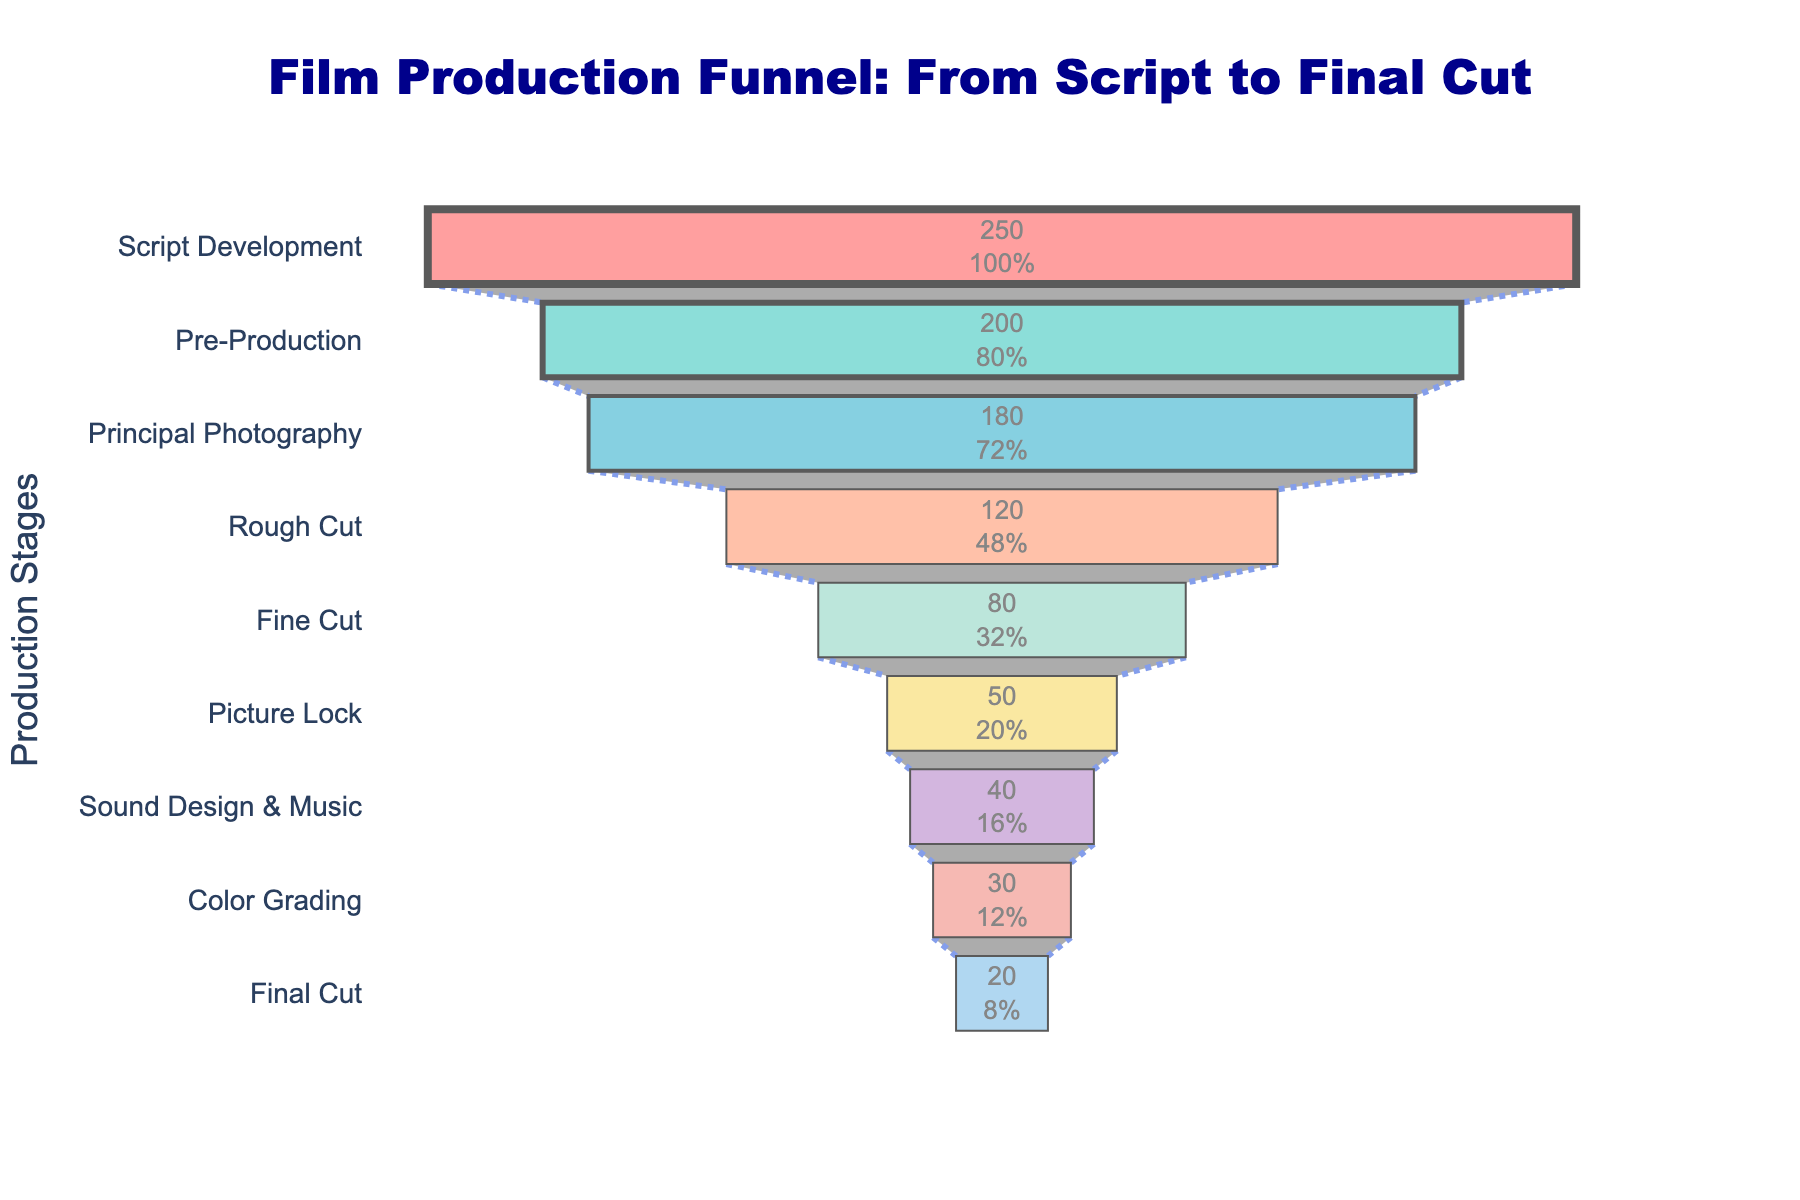What is the title of the funnel chart? The title appears at the top of the funnel chart and indicates the overall theme or topic.
Answer: Film Production Funnel: From Script to Final Cut Which stage has the most people involved? By examining the y-axis labels and the lengths of the bars in the funnel chart, the longest bar corresponds to the stage with the most people involved.
Answer: Script Development How many stages are depicted in the funnel chart? Count the number of distinct stages listed along the y-axis.
Answer: 9 What stage follows Principal Photography in the film production process? Identify the position of Principal Photography on the y-axis and then see which stage is listed immediately after it.
Answer: Rough Cut How many people are involved in the Final Cut stage, and what percent of the initial stage does this represent? Look at the value inside the bar for the Final Cut stage. The percentage can be seen as well.
Answer: 20 people, 8% What is the total number of people involved in the stages from Pre-Production to Rough Cut? Add the values of the stages from Pre-Production through Rough Cut: 200 (Pre-Production) + 180 (Principal Photography) + 120 (Rough Cut).
Answer: 500 How many more people are involved in the Script Development stage compared to the Sound Design & Music stage? Subtract the number of people involved in the Sound Design & Music stage from the number involved in Script Development: 250 (Script Development) - 40 (Sound Design & Music).
Answer: 210 Which stages involve fewer than 50 people? Identify stages with values less than 50 by examining the text within the bars.
Answer: Sound Design & Music, Color Grading, Final Cut Between the Rough Cut and Fine Cut stages, which one experiences a greater reduction in the number of people involved? Compare the difference between the number of people in Rough Cut and Fine Cut: 120 (Rough Cut) - 80 (Fine Cut).
Answer: Rough Cut What is the difference in the number of people between Principal Photography and Fine Cut stages? Subtract the number of people in the Fine Cut stage from those in the Principal Photography stage: 180 (Principal Photography) - 80 (Fine Cut).
Answer: 100 